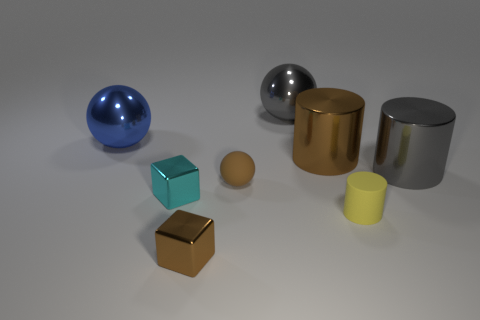Add 1 tiny brown cubes. How many objects exist? 9 Subtract all cylinders. How many objects are left? 5 Add 5 big metallic things. How many big metallic things exist? 9 Subtract 1 brown cubes. How many objects are left? 7 Subtract all big gray shiny objects. Subtract all small brown matte blocks. How many objects are left? 6 Add 4 big gray balls. How many big gray balls are left? 5 